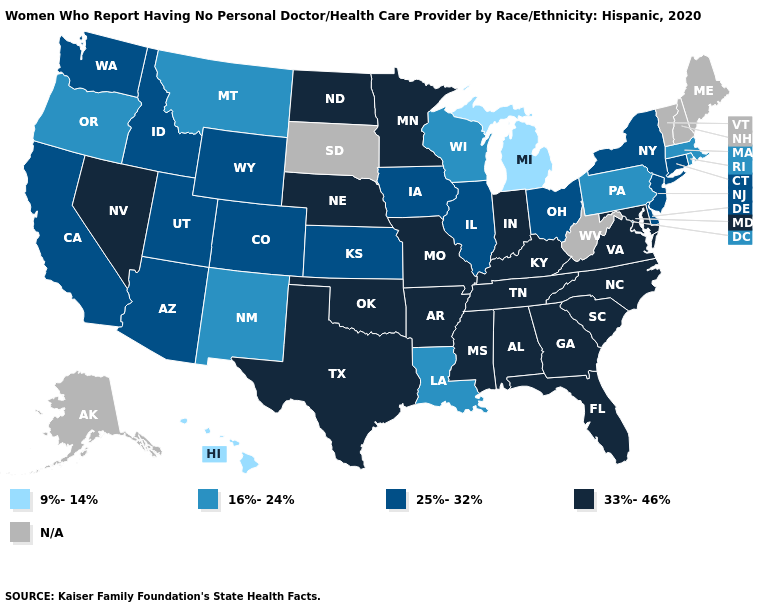What is the highest value in the West ?
Concise answer only. 33%-46%. Does Ohio have the highest value in the MidWest?
Concise answer only. No. What is the value of Wyoming?
Concise answer only. 25%-32%. How many symbols are there in the legend?
Short answer required. 5. Is the legend a continuous bar?
Concise answer only. No. Name the states that have a value in the range 33%-46%?
Give a very brief answer. Alabama, Arkansas, Florida, Georgia, Indiana, Kentucky, Maryland, Minnesota, Mississippi, Missouri, Nebraska, Nevada, North Carolina, North Dakota, Oklahoma, South Carolina, Tennessee, Texas, Virginia. Does the map have missing data?
Concise answer only. Yes. What is the highest value in states that border Tennessee?
Write a very short answer. 33%-46%. What is the highest value in the MidWest ?
Keep it brief. 33%-46%. Does Texas have the highest value in the South?
Be succinct. Yes. What is the highest value in states that border Ohio?
Give a very brief answer. 33%-46%. Name the states that have a value in the range 9%-14%?
Concise answer only. Hawaii, Michigan. What is the value of New York?
Be succinct. 25%-32%. 